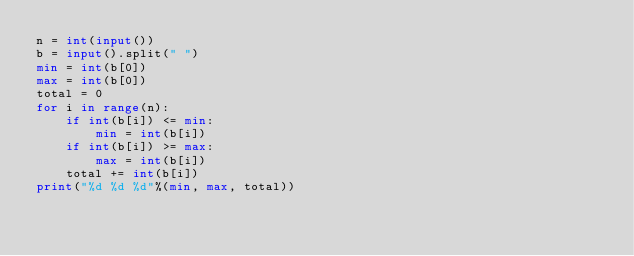<code> <loc_0><loc_0><loc_500><loc_500><_Python_>n = int(input())
b = input().split(" ")
min = int(b[0])
max = int(b[0])
total = 0
for i in range(n):
    if int(b[i]) <= min:
        min = int(b[i])
    if int(b[i]) >= max:
        max = int(b[i])
    total += int(b[i])
print("%d %d %d"%(min, max, total))

</code> 